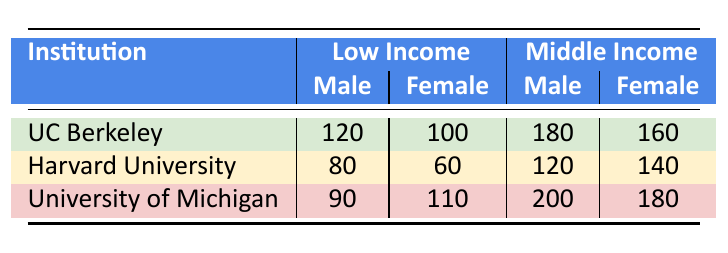What is the total enrollment of Low Income male students at all institutions? To find the total enrollment of Low Income male students, sum the enrollment counts for male students under the Low Income category from all institutions: UC Berkeley (120) + Harvard University (80) + University of Michigan (90) = 290.
Answer: 290 Which institution has the highest enrollment of Middle Income female students? By comparing the enrollment counts of Middle Income female students from each institution: UC Berkeley (160), Harvard University (140), and University of Michigan (180), we see that University of Michigan has the highest count.
Answer: University of Michigan Is the number of Low Income female students at UC Berkeley greater than at Harvard University? Looking at the enrollment for Low Income female students: UC Berkeley has 100, while Harvard University has 60. Since 100 is greater than 60, the statement is true.
Answer: Yes What is the difference in enrollment between Middle Income male and female students at University of Michigan? At University of Michigan, the enrollment count for Middle Income male students is 200 and for female students is 180. The difference is calculated as 200 - 180 = 20.
Answer: 20 Calculate the average number of female students enrolled across all institutions. The total enrollment of female students is UC Berkeley (100 + 160) + Harvard University (60 + 140) + University of Michigan (110 + 180) = 100 + 160 + 60 + 140 + 110 + 180 = 810. There are 6 data points (female counts) so the average is 810 / 6 = 135.
Answer: 135 Are there more Low Income male students at UC Berkeley than at University of Michigan? Compare the enrollment of Low Income male students: UC Berkeley has 120 and University of Michigan has 90. Since 120 is greater than 90, the answer is yes.
Answer: Yes What is the total enrollment of Middle Income students at Harvard University? To find the total enrollment of Middle Income students at Harvard University, add the counts of both male (120) and female (140) Middle Income students: 120 + 140 = 260.
Answer: 260 Which gender has a higher total enrollment overall at UC Berkeley? First, calculate the total enrollment by gender at UC Berkeley: Males (120 + 180 = 300) and Females (100 + 160 = 260). Males (300) are greater than Females (260), therefore Males have higher enrollment.
Answer: Male What is the enrollment ratio of Low Income male to Low Income female students at all institutions? Total Low Income male students are 120 (UC Berkeley) + 80 (Harvard) + 90 (Michigan) = 290. Total Low Income female students are 100 (UC Berkeley) + 60 (Harvard) + 110 (Michigan) = 270. The ratio is 290:270, which simplifies to 29:27.
Answer: 29:27 